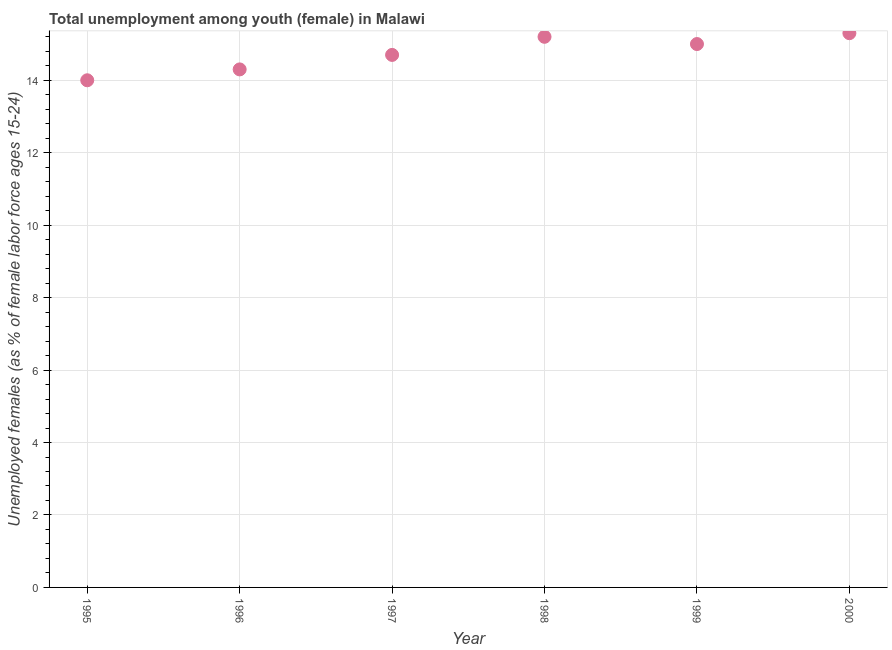What is the unemployed female youth population in 1998?
Provide a succinct answer. 15.2. Across all years, what is the maximum unemployed female youth population?
Provide a succinct answer. 15.3. Across all years, what is the minimum unemployed female youth population?
Offer a terse response. 14. In which year was the unemployed female youth population minimum?
Keep it short and to the point. 1995. What is the sum of the unemployed female youth population?
Keep it short and to the point. 88.5. What is the difference between the unemployed female youth population in 1997 and 1998?
Provide a short and direct response. -0.5. What is the average unemployed female youth population per year?
Keep it short and to the point. 14.75. What is the median unemployed female youth population?
Your response must be concise. 14.85. What is the ratio of the unemployed female youth population in 1996 to that in 1998?
Provide a short and direct response. 0.94. Is the unemployed female youth population in 1997 less than that in 2000?
Your response must be concise. Yes. What is the difference between the highest and the second highest unemployed female youth population?
Provide a succinct answer. 0.1. Is the sum of the unemployed female youth population in 1996 and 1999 greater than the maximum unemployed female youth population across all years?
Give a very brief answer. Yes. What is the difference between the highest and the lowest unemployed female youth population?
Ensure brevity in your answer.  1.3. In how many years, is the unemployed female youth population greater than the average unemployed female youth population taken over all years?
Keep it short and to the point. 3. Does the unemployed female youth population monotonically increase over the years?
Offer a terse response. No. How many dotlines are there?
Offer a terse response. 1. Does the graph contain grids?
Your answer should be very brief. Yes. What is the title of the graph?
Offer a terse response. Total unemployment among youth (female) in Malawi. What is the label or title of the Y-axis?
Ensure brevity in your answer.  Unemployed females (as % of female labor force ages 15-24). What is the Unemployed females (as % of female labor force ages 15-24) in 1995?
Give a very brief answer. 14. What is the Unemployed females (as % of female labor force ages 15-24) in 1996?
Keep it short and to the point. 14.3. What is the Unemployed females (as % of female labor force ages 15-24) in 1997?
Provide a short and direct response. 14.7. What is the Unemployed females (as % of female labor force ages 15-24) in 1998?
Keep it short and to the point. 15.2. What is the Unemployed females (as % of female labor force ages 15-24) in 2000?
Ensure brevity in your answer.  15.3. What is the difference between the Unemployed females (as % of female labor force ages 15-24) in 1995 and 1996?
Give a very brief answer. -0.3. What is the difference between the Unemployed females (as % of female labor force ages 15-24) in 1995 and 1997?
Ensure brevity in your answer.  -0.7. What is the difference between the Unemployed females (as % of female labor force ages 15-24) in 1995 and 1998?
Keep it short and to the point. -1.2. What is the difference between the Unemployed females (as % of female labor force ages 15-24) in 1995 and 1999?
Provide a succinct answer. -1. What is the difference between the Unemployed females (as % of female labor force ages 15-24) in 1995 and 2000?
Offer a terse response. -1.3. What is the difference between the Unemployed females (as % of female labor force ages 15-24) in 1998 and 1999?
Keep it short and to the point. 0.2. What is the ratio of the Unemployed females (as % of female labor force ages 15-24) in 1995 to that in 1998?
Your response must be concise. 0.92. What is the ratio of the Unemployed females (as % of female labor force ages 15-24) in 1995 to that in 1999?
Provide a succinct answer. 0.93. What is the ratio of the Unemployed females (as % of female labor force ages 15-24) in 1995 to that in 2000?
Ensure brevity in your answer.  0.92. What is the ratio of the Unemployed females (as % of female labor force ages 15-24) in 1996 to that in 1997?
Offer a terse response. 0.97. What is the ratio of the Unemployed females (as % of female labor force ages 15-24) in 1996 to that in 1998?
Provide a succinct answer. 0.94. What is the ratio of the Unemployed females (as % of female labor force ages 15-24) in 1996 to that in 1999?
Provide a short and direct response. 0.95. What is the ratio of the Unemployed females (as % of female labor force ages 15-24) in 1996 to that in 2000?
Keep it short and to the point. 0.94. What is the ratio of the Unemployed females (as % of female labor force ages 15-24) in 1997 to that in 1998?
Provide a succinct answer. 0.97. 